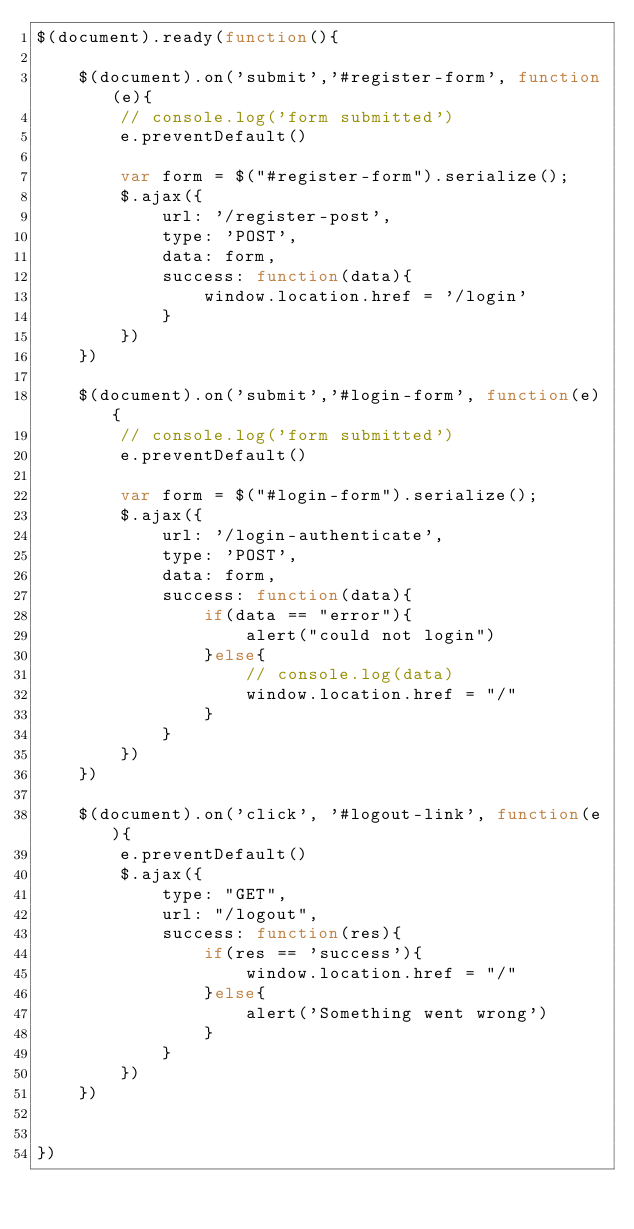<code> <loc_0><loc_0><loc_500><loc_500><_JavaScript_>$(document).ready(function(){

    $(document).on('submit','#register-form', function(e){
        // console.log('form submitted')
        e.preventDefault()
        
        var form = $("#register-form").serialize();
        $.ajax({
            url: '/register-post',
            type: 'POST',
            data: form,
            success: function(data){
                window.location.href = '/login'
            }
        })
    })

    $(document).on('submit','#login-form', function(e){
        // console.log('form submitted')
        e.preventDefault()

        var form = $("#login-form").serialize();
        $.ajax({
            url: '/login-authenticate',
            type: 'POST',
            data: form,
            success: function(data){
                if(data == "error"){
                    alert("could not login")
                }else{
                    // console.log(data)
                    window.location.href = "/"
                }
            }
        })
    })

    $(document).on('click', '#logout-link', function(e){
        e.preventDefault()
        $.ajax({
            type: "GET",
            url: "/logout",
            success: function(res){
                if(res == 'success'){
                    window.location.href = "/"
                }else{
                    alert('Something went wrong')
                }
            }
        })
    })


})</code> 